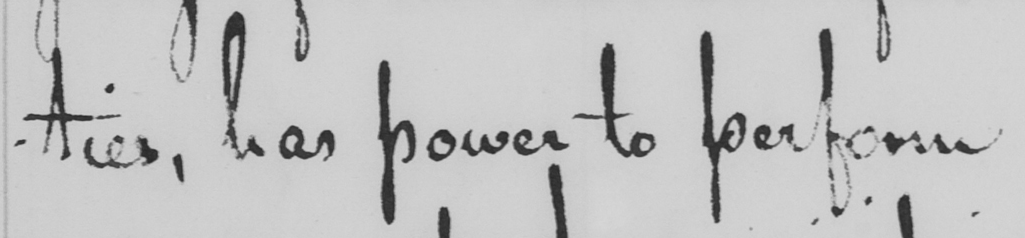Please transcribe the handwritten text in this image. -ties , has power to perform 